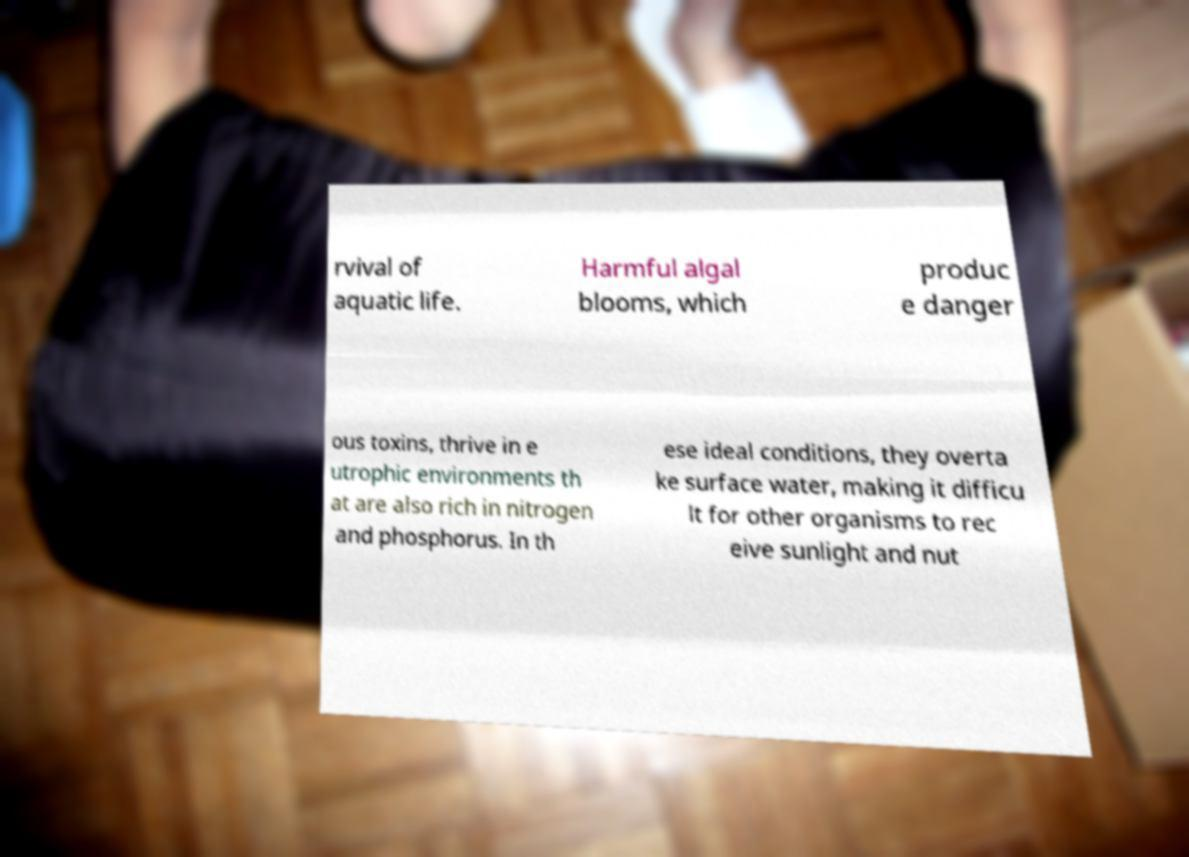For documentation purposes, I need the text within this image transcribed. Could you provide that? rvival of aquatic life. Harmful algal blooms, which produc e danger ous toxins, thrive in e utrophic environments th at are also rich in nitrogen and phosphorus. In th ese ideal conditions, they overta ke surface water, making it difficu lt for other organisms to rec eive sunlight and nut 